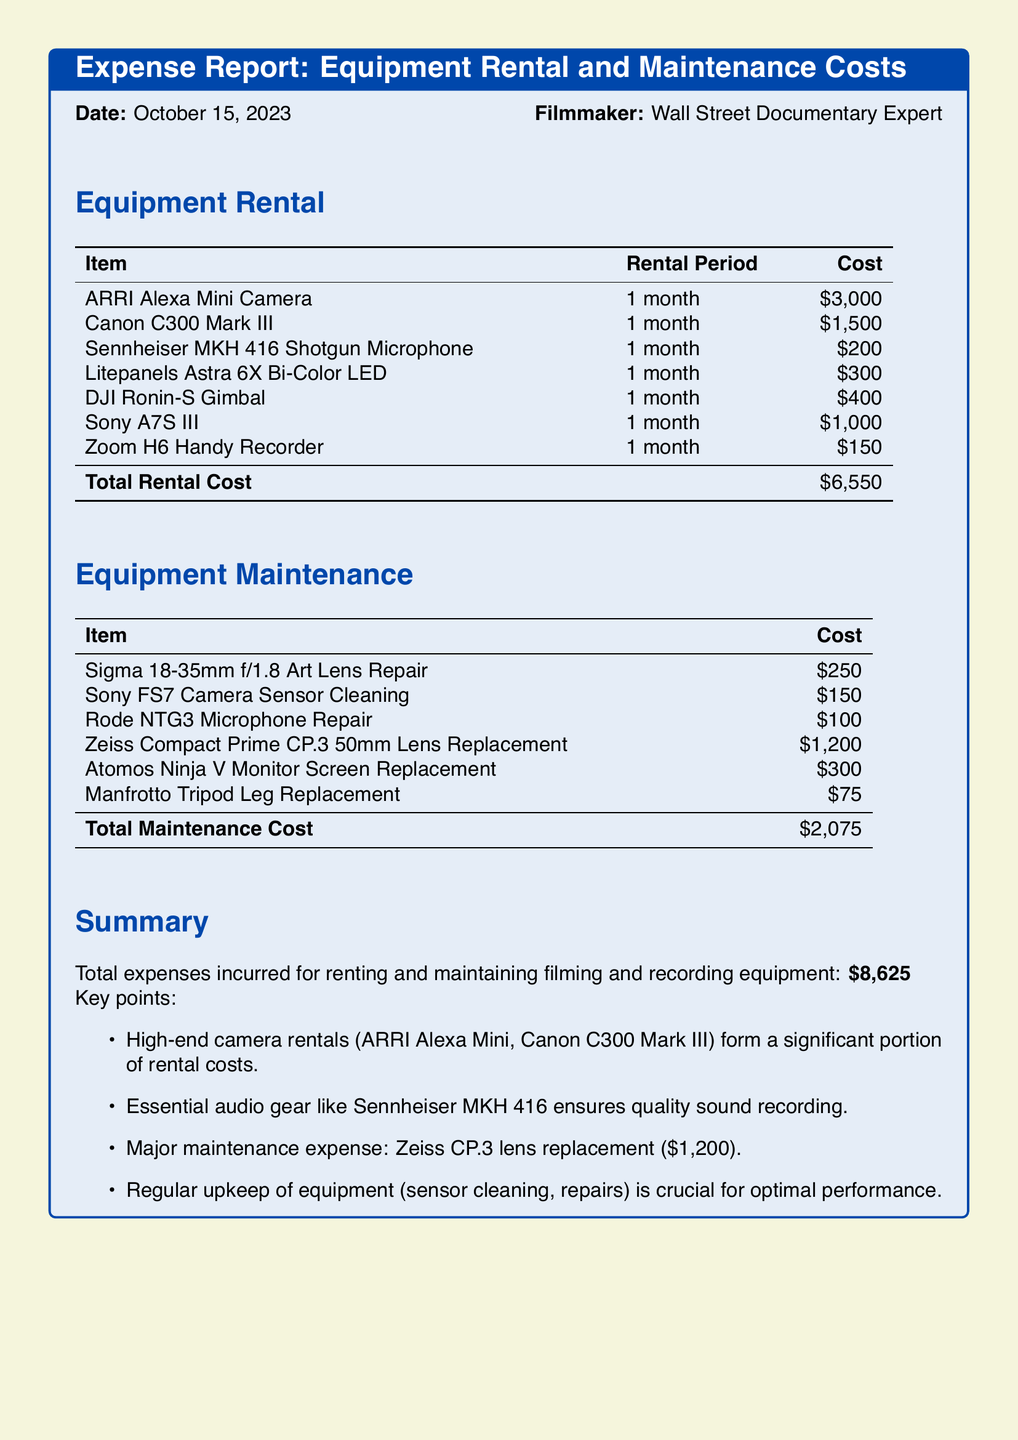What is the total rental cost? The total rental cost is calculated by summing the individual rental expenses listed in the document, which equals $3,000 + $1,500 + $200 + $300 + $400 + $1,000 + $150 = $6,550.
Answer: $6,550 What item has the highest maintenance cost? The document lists maintenance costs for various items, and the highest is the Zeiss Compact Prime CP.3 50mm Lens Replacement costing $1,200.
Answer: Zeiss Compact Prime CP.3 50mm Lens Replacement What is the total maintenance cost? The total maintenance cost is derived from the sum of all listed maintenance expenses, which equals $250 + $150 + $100 + $1,200 + $300 + $75 = $2,075.
Answer: $2,075 How long was the ARRI Alexa Mini Camera rented? The rental period for the ARRI Alexa Mini Camera is specified as 1 month in the document.
Answer: 1 month What key point emphasizes the importance of audio gear? A key point mentions that essential audio gear like Sennheiser MKH 416 ensures quality sound recording, highlighting its importance in filming.
Answer: Essential audio gear like Sennheiser MKH 416 ensures quality sound recording What is the date of the expense report? The expense report specifies the date as October 15, 2023, providing clarity on when the expenses were incurred.
Answer: October 15, 2023 What is the total expense for both rental and maintenance? The total expense is the combined total of rental costs ($6,550) and maintenance costs ($2,075), resulting in $8,625.
Answer: $8,625 Which item was repaired for $100? The Rode NTG3 Microphone Repair is specifically noted as having a cost of $100 in the maintenance section.
Answer: Rode NTG3 Microphone Repair 